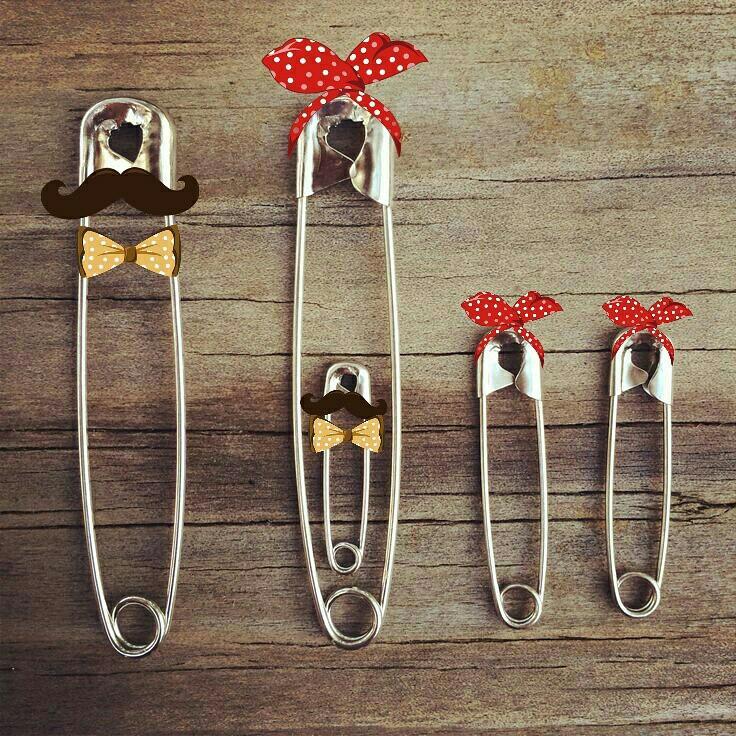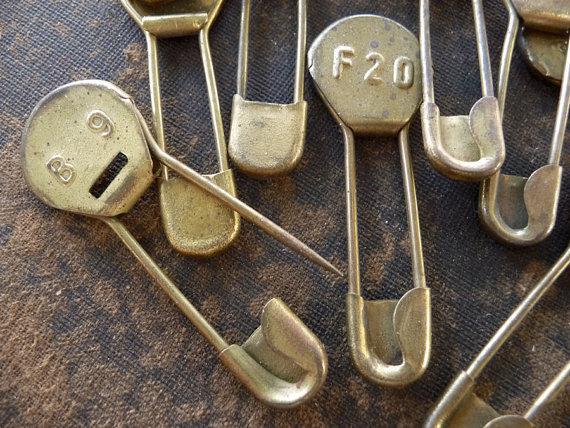The first image is the image on the left, the second image is the image on the right. Considering the images on both sides, is "Some safety pins have letters and numbers on them." valid? Answer yes or no. Yes. 